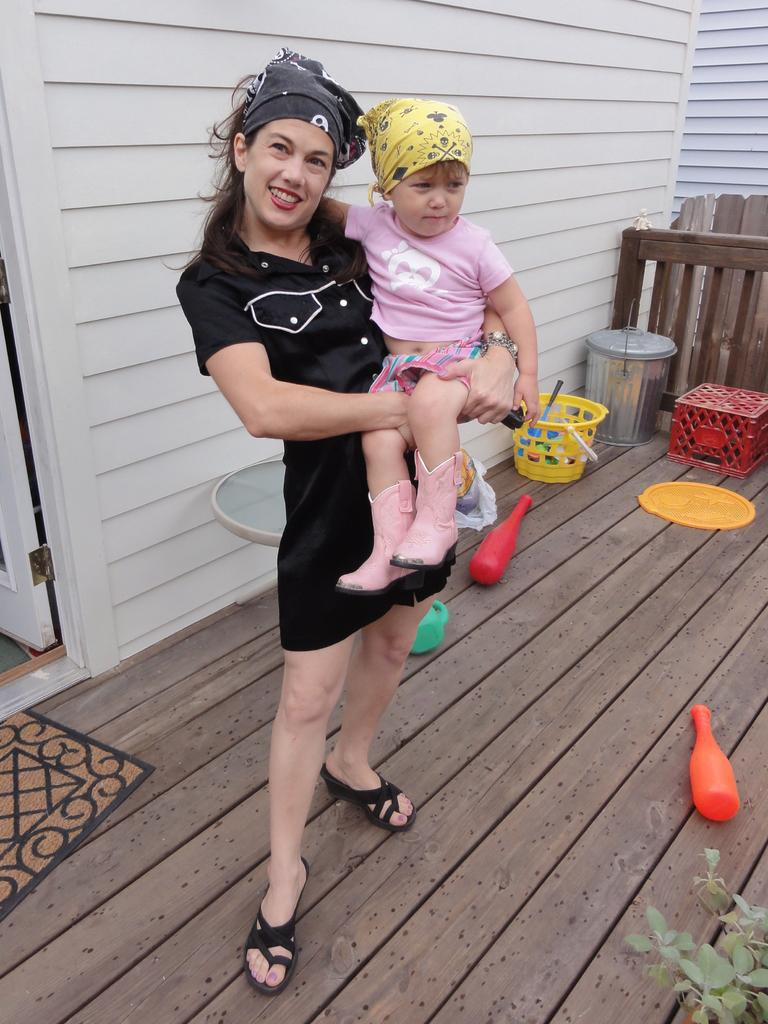What is the woman in the image holding? The woman is holding a baby in the image. What can be seen in the background of the image? There is a wall in the background of the image. What items are present in the image that might be used for play? There are toys in the image. What type of container is visible in the image? There is a basket in the image. What type of plant is present in the image? There is a plant in the image. What is on the floor in the image? There is a door mat on the floor in the image. What type of fuel is the airplane using in the image? There is no airplane present in the image, so it is not possible to determine what type of fuel it might be using. How many feet are visible in the image? There are no feet visible in the image. 